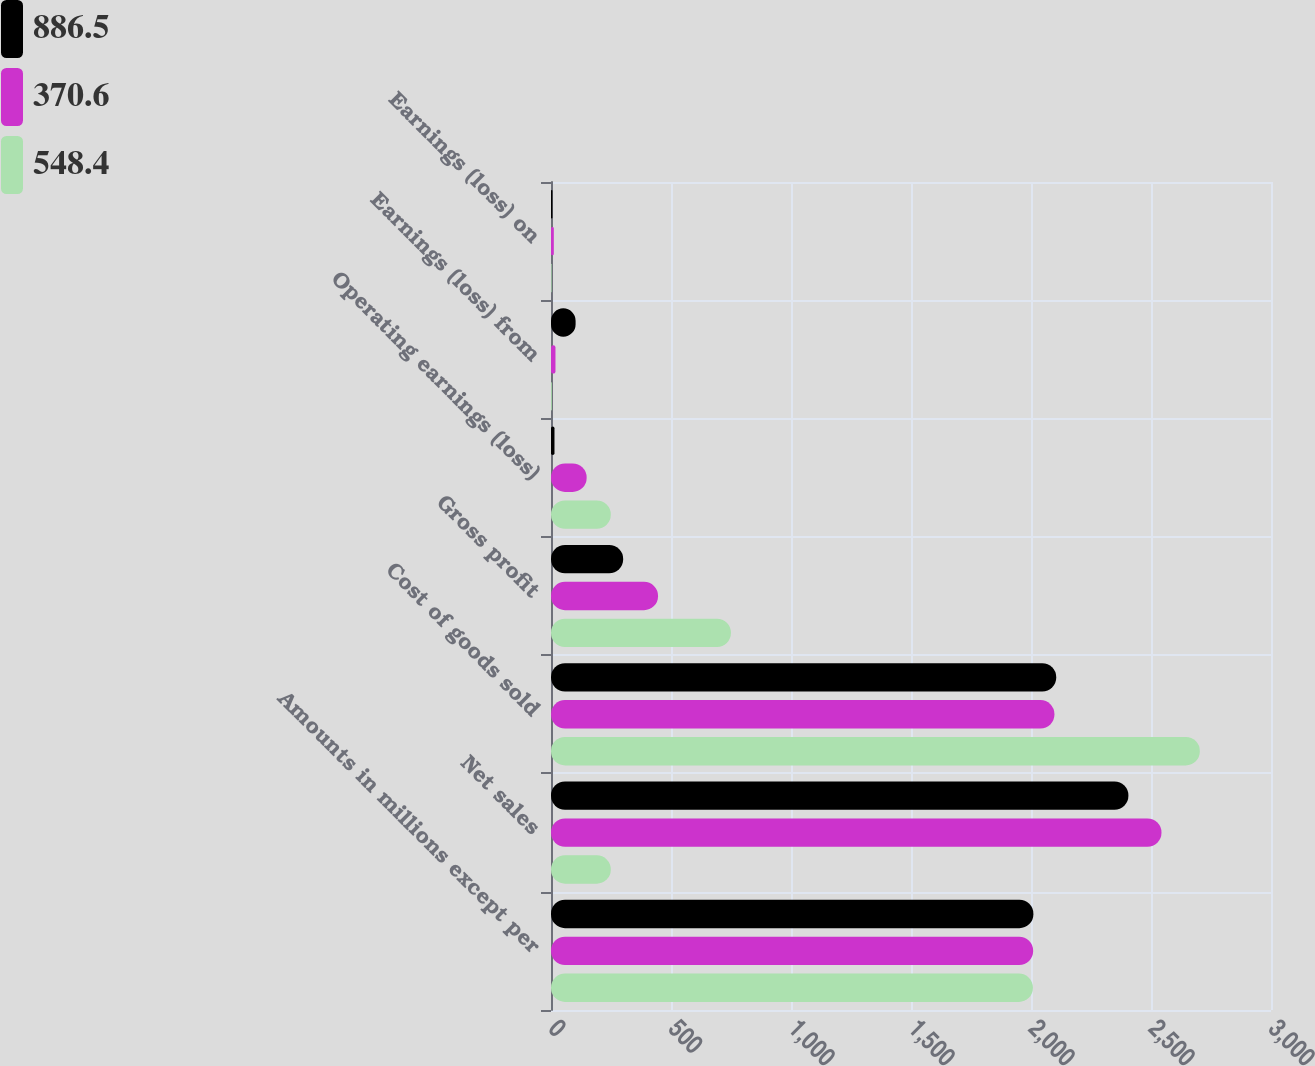<chart> <loc_0><loc_0><loc_500><loc_500><stacked_bar_chart><ecel><fcel>Amounts in millions except per<fcel>Net sales<fcel>Cost of goods sold<fcel>Gross profit<fcel>Operating earnings (loss)<fcel>Earnings (loss) from<fcel>Earnings (loss) on<nl><fcel>886.5<fcel>2010<fcel>2405.9<fcel>2105.2<fcel>300.7<fcel>14.5<fcel>102.5<fcel>6<nl><fcel>370.6<fcel>2009<fcel>2543.7<fcel>2097.7<fcel>446<fcel>148.5<fcel>18.6<fcel>11.7<nl><fcel>548.4<fcel>2008<fcel>249.1<fcel>2703.4<fcel>749.7<fcel>249.1<fcel>3.4<fcel>2.5<nl></chart> 